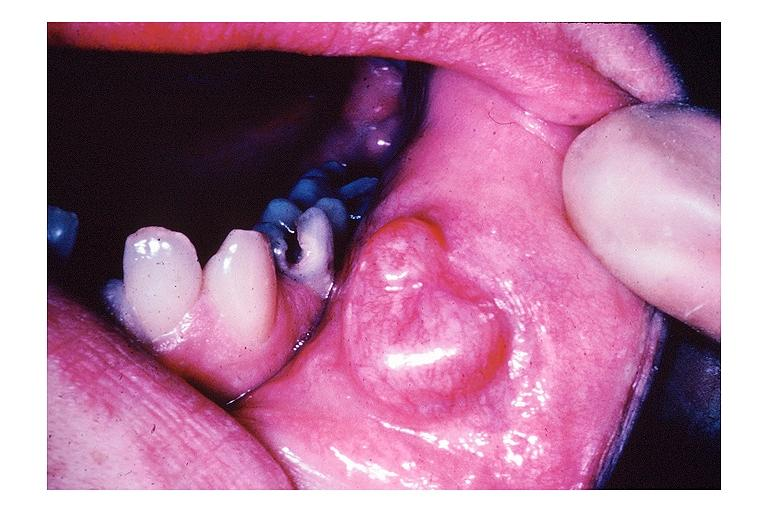where is this?
Answer the question using a single word or phrase. Oral 